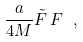Convert formula to latex. <formula><loc_0><loc_0><loc_500><loc_500>\frac { a } { 4 M } { \tilde { F } } \, F \ ,</formula> 